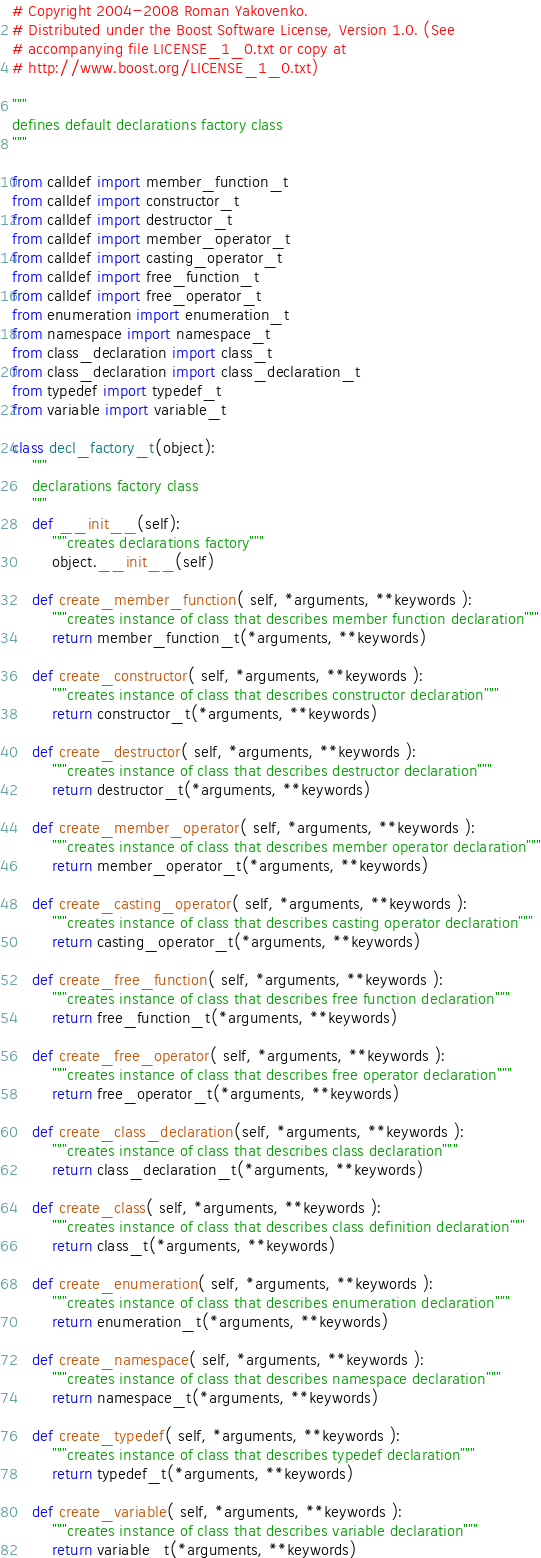Convert code to text. <code><loc_0><loc_0><loc_500><loc_500><_Python_># Copyright 2004-2008 Roman Yakovenko.
# Distributed under the Boost Software License, Version 1.0. (See
# accompanying file LICENSE_1_0.txt or copy at
# http://www.boost.org/LICENSE_1_0.txt)

"""
defines default declarations factory class
"""

from calldef import member_function_t
from calldef import constructor_t
from calldef import destructor_t
from calldef import member_operator_t
from calldef import casting_operator_t
from calldef import free_function_t
from calldef import free_operator_t
from enumeration import enumeration_t
from namespace import namespace_t
from class_declaration import class_t
from class_declaration import class_declaration_t
from typedef import typedef_t
from variable import variable_t

class decl_factory_t(object):
    """
    declarations factory class
    """
    def __init__(self):
        """creates declarations factory"""
        object.__init__(self)

    def create_member_function( self, *arguments, **keywords ):
        """creates instance of class that describes member function declaration"""
        return member_function_t(*arguments, **keywords)

    def create_constructor( self, *arguments, **keywords ):
        """creates instance of class that describes constructor declaration"""
        return constructor_t(*arguments, **keywords)

    def create_destructor( self, *arguments, **keywords ):
        """creates instance of class that describes destructor declaration"""
        return destructor_t(*arguments, **keywords)

    def create_member_operator( self, *arguments, **keywords ):
        """creates instance of class that describes member operator declaration"""
        return member_operator_t(*arguments, **keywords)

    def create_casting_operator( self, *arguments, **keywords ):
        """creates instance of class that describes casting operator declaration"""
        return casting_operator_t(*arguments, **keywords)

    def create_free_function( self, *arguments, **keywords ):
        """creates instance of class that describes free function declaration"""
        return free_function_t(*arguments, **keywords)

    def create_free_operator( self, *arguments, **keywords ):
        """creates instance of class that describes free operator declaration"""
        return free_operator_t(*arguments, **keywords)

    def create_class_declaration(self, *arguments, **keywords ):
        """creates instance of class that describes class declaration"""
        return class_declaration_t(*arguments, **keywords)

    def create_class( self, *arguments, **keywords ):
        """creates instance of class that describes class definition declaration"""
        return class_t(*arguments, **keywords)

    def create_enumeration( self, *arguments, **keywords ):
        """creates instance of class that describes enumeration declaration"""
        return enumeration_t(*arguments, **keywords)

    def create_namespace( self, *arguments, **keywords ):
        """creates instance of class that describes namespace declaration"""
        return namespace_t(*arguments, **keywords)

    def create_typedef( self, *arguments, **keywords ):
        """creates instance of class that describes typedef declaration"""
        return typedef_t(*arguments, **keywords)

    def create_variable( self, *arguments, **keywords ):
        """creates instance of class that describes variable declaration"""
        return variable_t(*arguments, **keywords)
</code> 